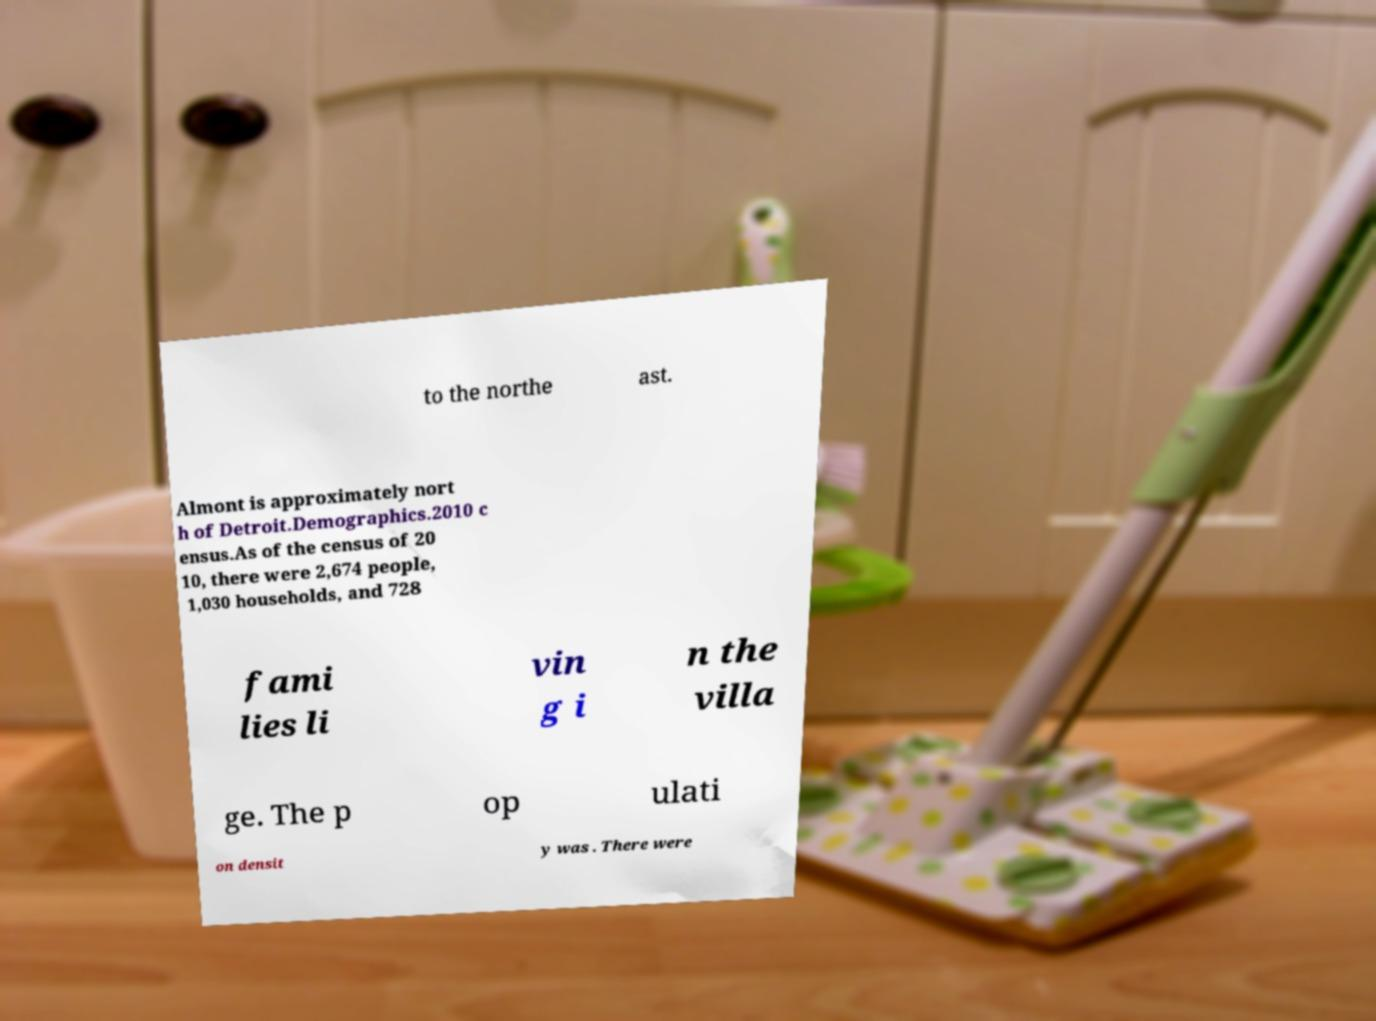Could you extract and type out the text from this image? to the northe ast. Almont is approximately nort h of Detroit.Demographics.2010 c ensus.As of the census of 20 10, there were 2,674 people, 1,030 households, and 728 fami lies li vin g i n the villa ge. The p op ulati on densit y was . There were 